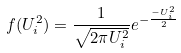Convert formula to latex. <formula><loc_0><loc_0><loc_500><loc_500>f ( U _ { i } ^ { 2 } ) = \frac { 1 } { \sqrt { 2 \pi U _ { i } ^ { 2 } } } e ^ { - \frac { - U _ { i } ^ { 2 } } { 2 } }</formula> 